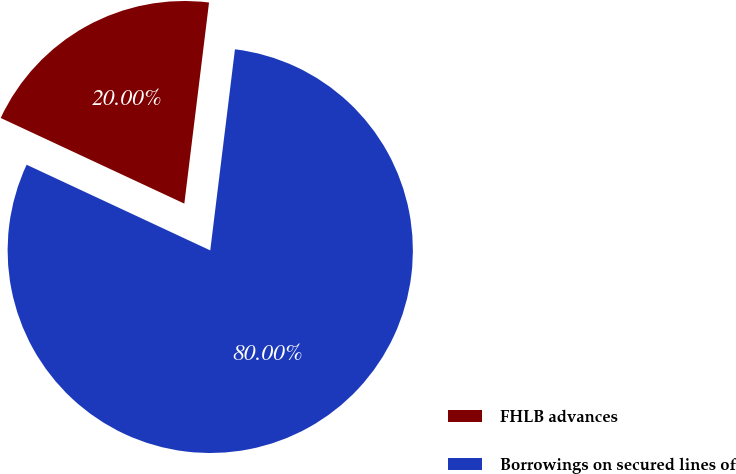Convert chart to OTSL. <chart><loc_0><loc_0><loc_500><loc_500><pie_chart><fcel>FHLB advances<fcel>Borrowings on secured lines of<nl><fcel>20.0%<fcel>80.0%<nl></chart> 